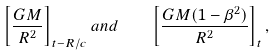<formula> <loc_0><loc_0><loc_500><loc_500>\left [ \frac { G M } { R ^ { 2 } } \right ] _ { t - R / c } a n d \quad \left [ \frac { G M ( 1 - \beta ^ { 2 } ) } { R ^ { 2 } } \right ] _ { t } ,</formula> 